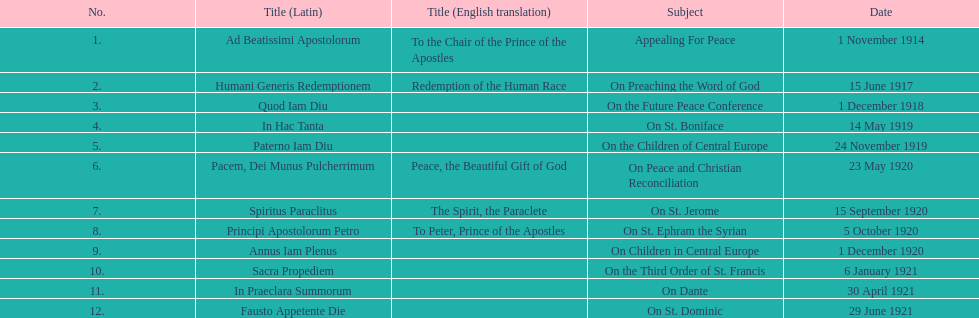How many titles correspond to a date in november? 2. 